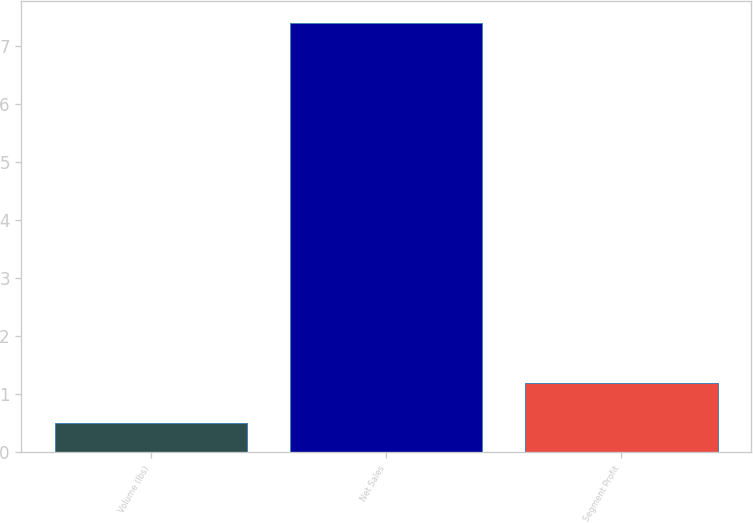Convert chart. <chart><loc_0><loc_0><loc_500><loc_500><bar_chart><fcel>Volume (lbs)<fcel>Net Sales<fcel>Segment Profit<nl><fcel>0.5<fcel>7.4<fcel>1.19<nl></chart> 